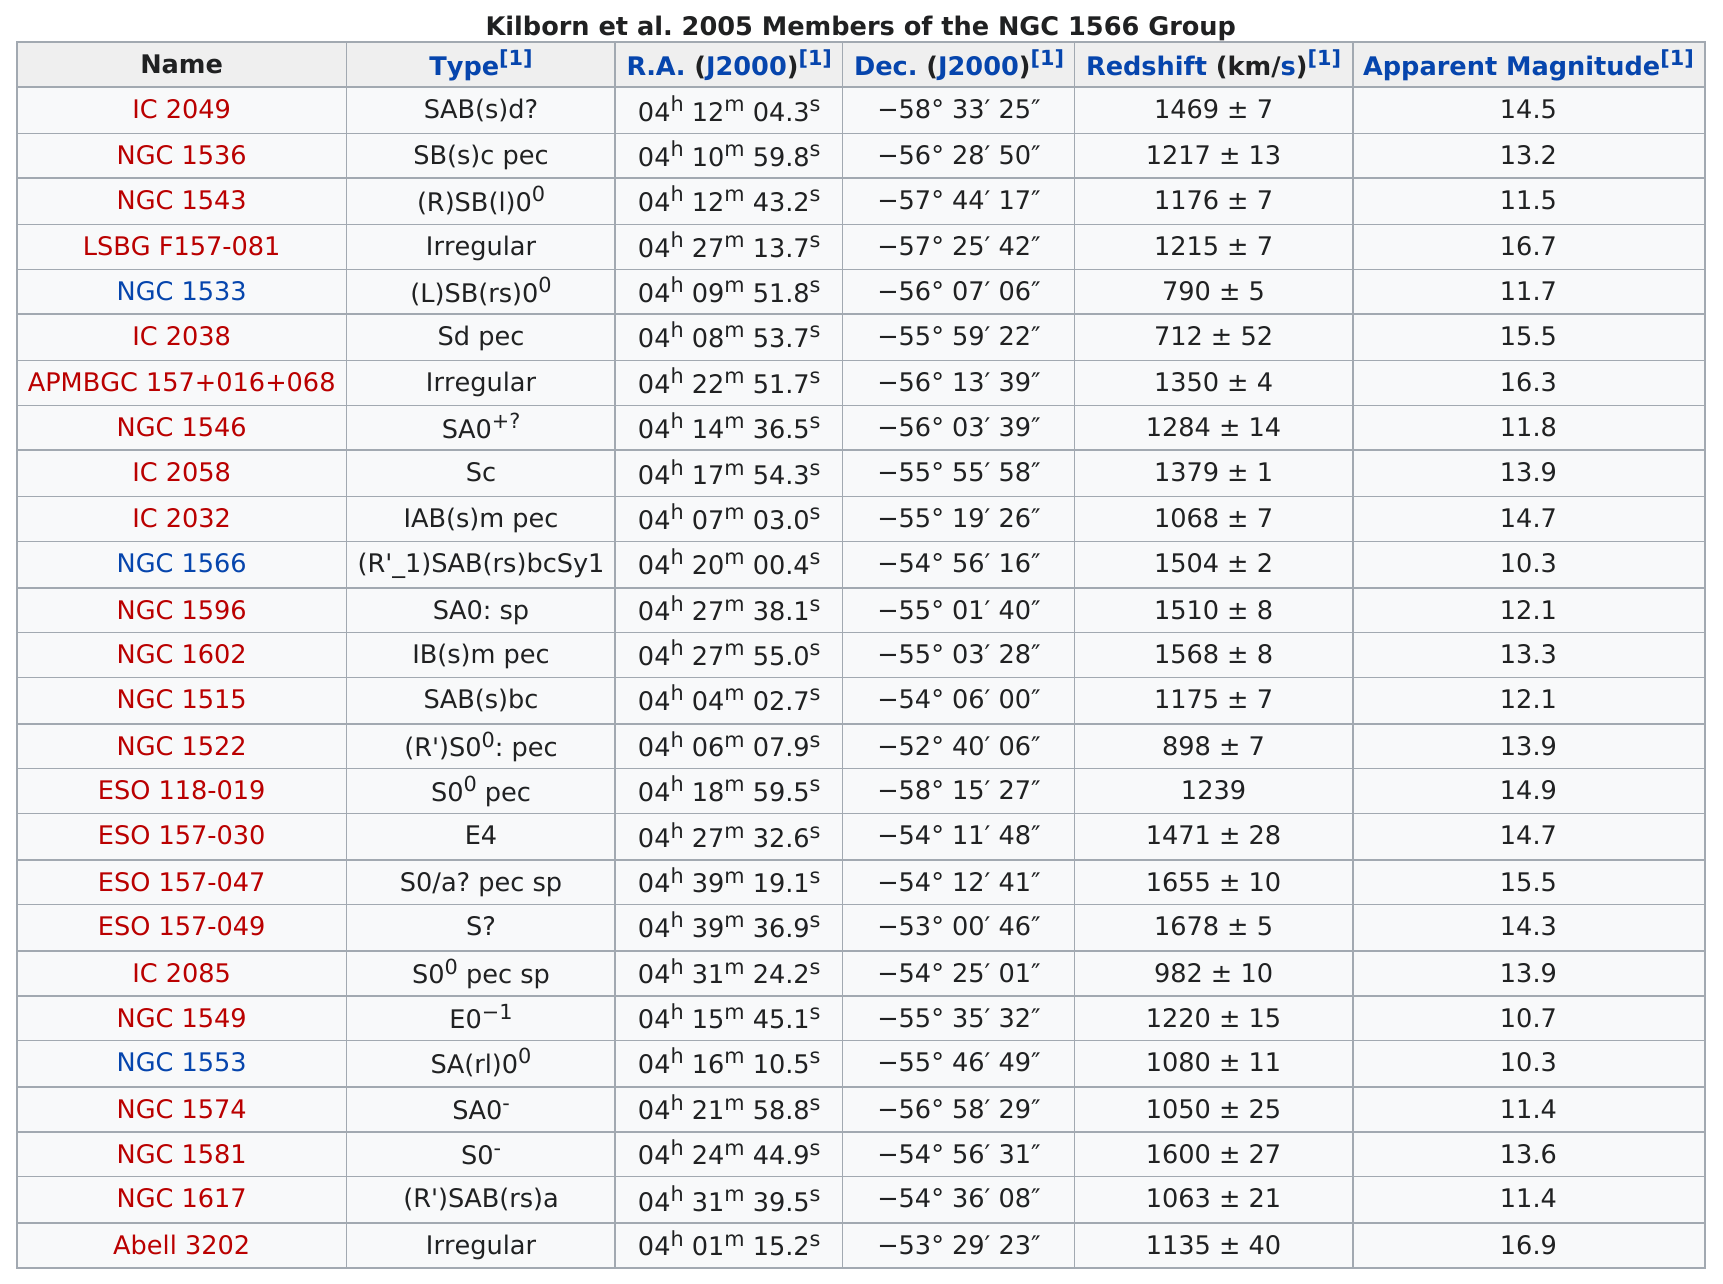List a handful of essential elements in this visual. There are 3 types of irregular forms in the language being studied. The member with the highest apparent magnitude in Abell 3202 is unknown. 